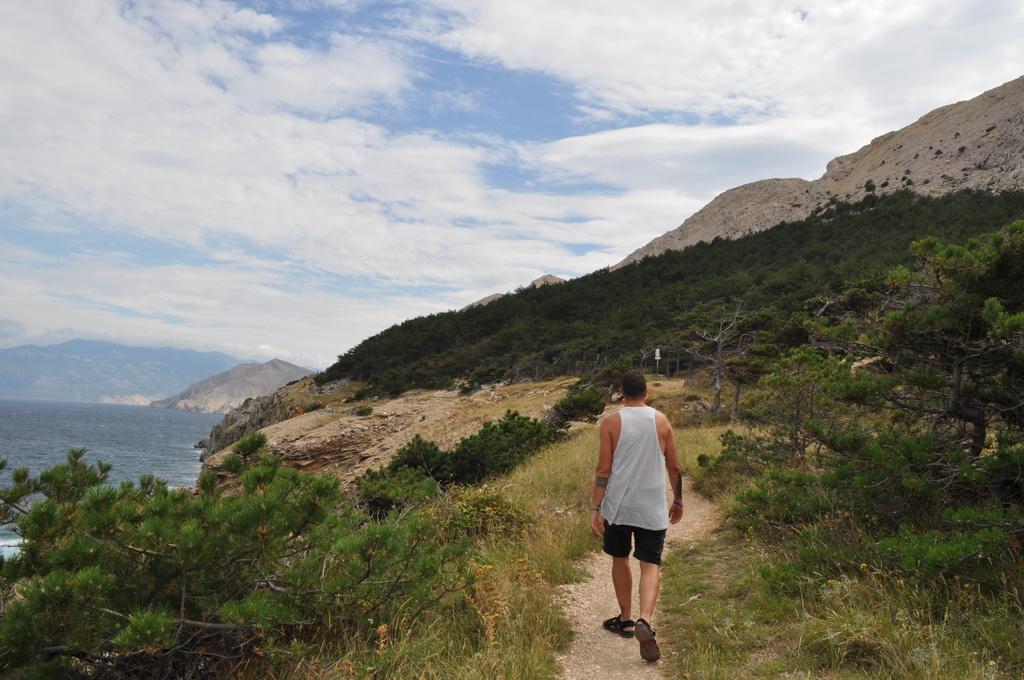Describe this image in one or two sentences. In the center of the image we can see a man walking and there are trees. On the left there is water. In the background there are hills and sky. At the bottom there is grass. 